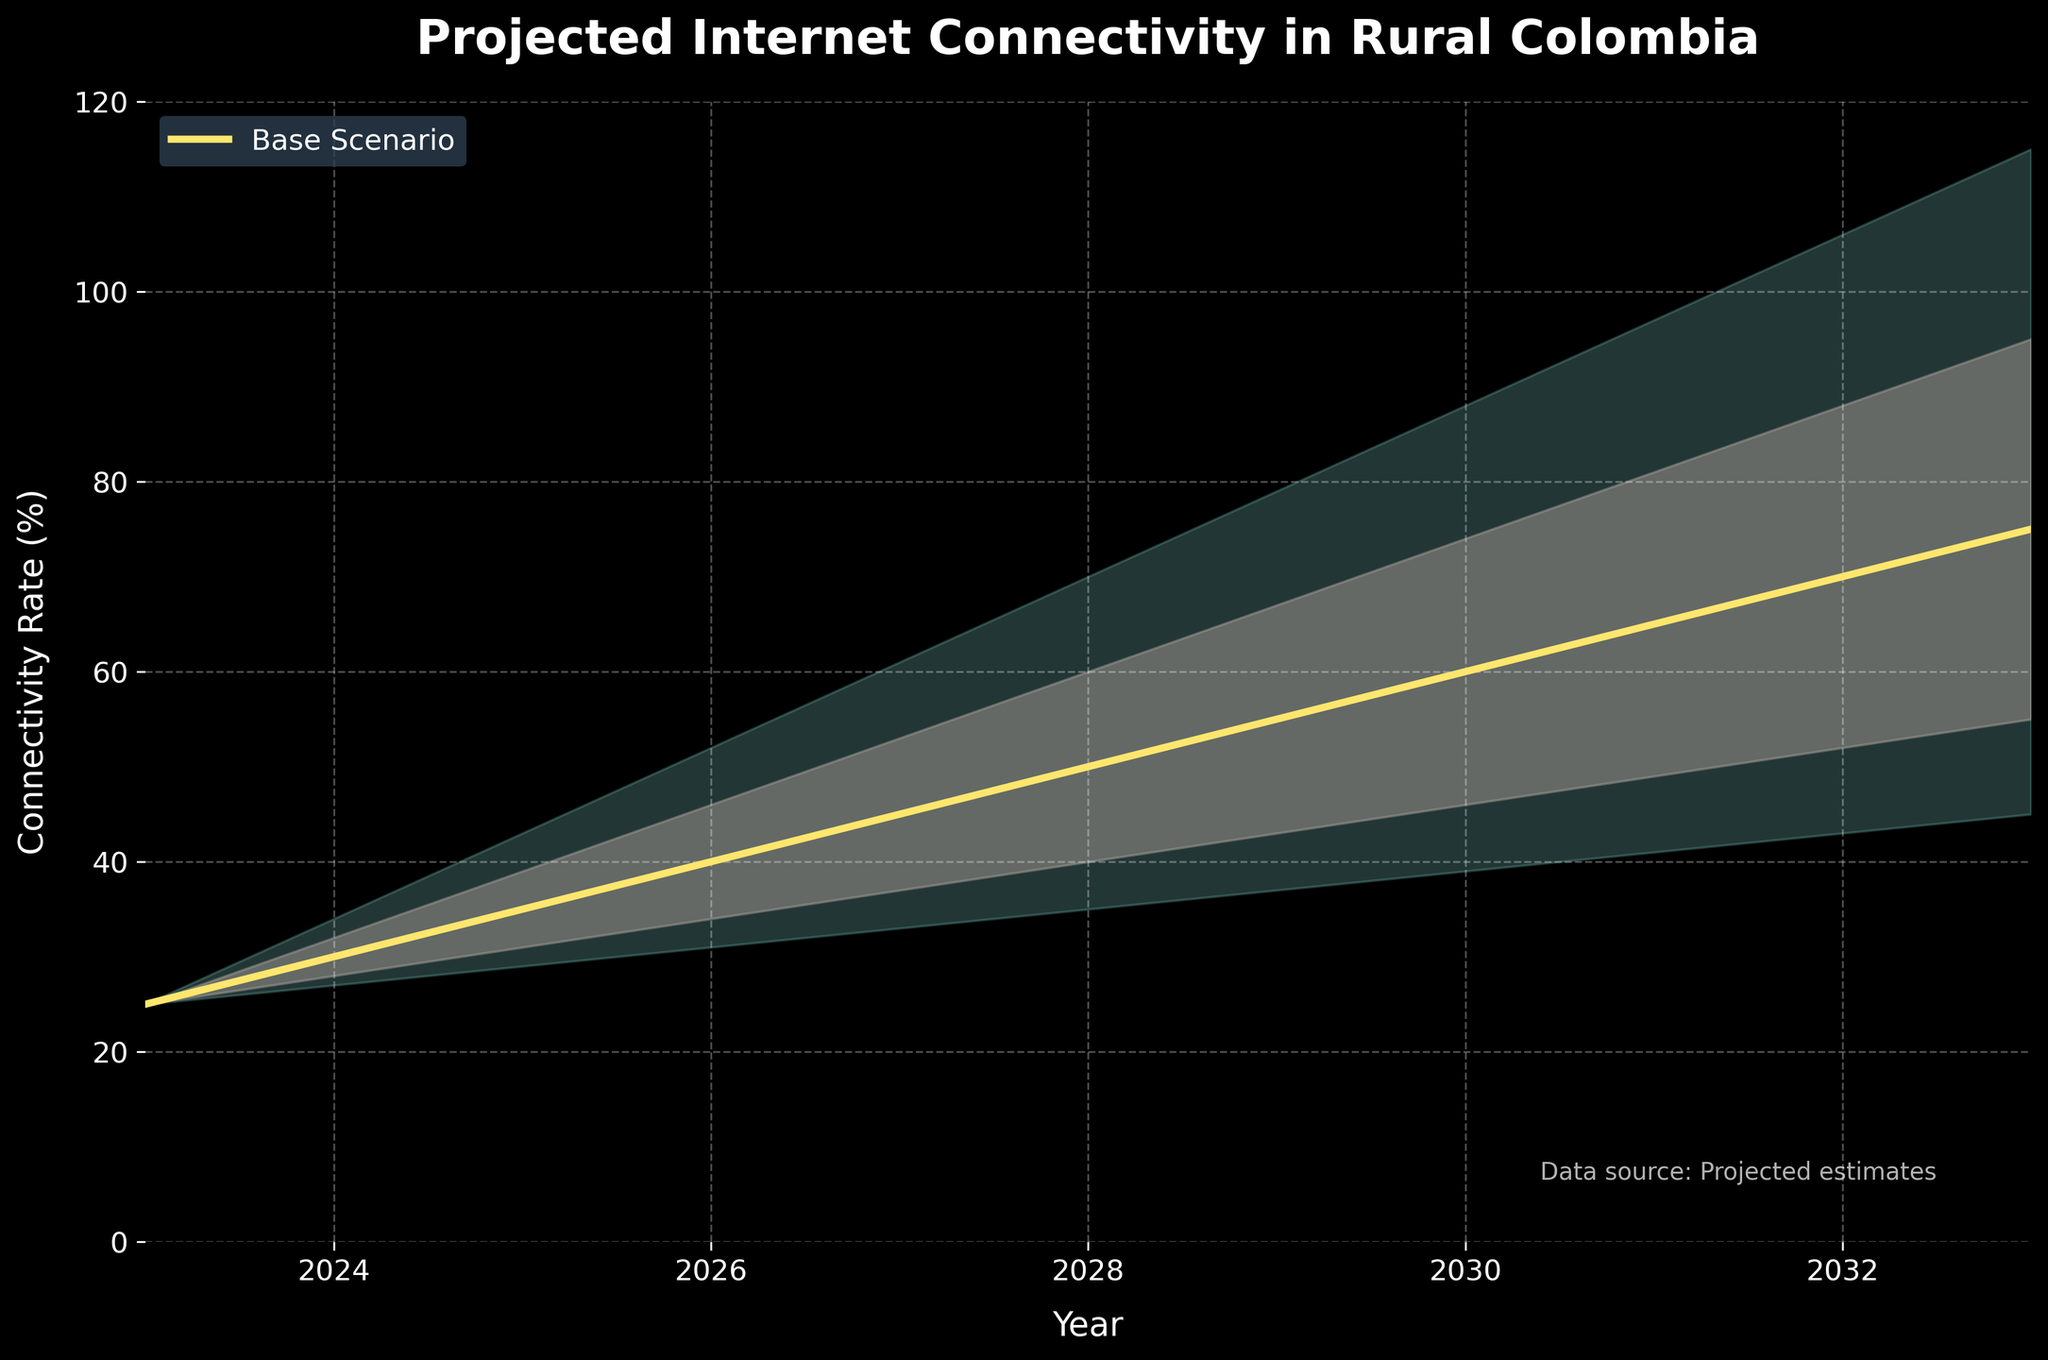What is the title of the chart? The title is written prominently at the top of the chart in large, bold font.
Answer: Projected Internet Connectivity in Rural Colombia What is the predicted connectivity rate in 2025 based on the base scenario? Locate the year 2025 on the x-axis and follow it up to the yellow line (base scenario). Read the corresponding y-value.
Answer: 35% What are the colors used in the chart to represent different scenarios? Analyzing the chart, the base scenario is represented by a yellow color, the optimistic and pessimistic ranges are represented by a gradient of colors from light to dark.
Answer: Yellow for base, gradient shades for others How does the connectivity rate in 2026 for the base scenario compare to the optimistic scenario? Find the year 2026 on the x-axis, then compare the y-values for the base scenario (yellow line) and the optimistic scenario (upper boundary of the shaded area).
Answer: Base: 40%, Optimistic: 52% What is the range between the pessimistic and optimistic scenarios in 2029? For the year 2029, determine the y-values for both the pessimistic and optimistic scenarios and calculate the difference.
Answer: 37 (79% - 42%) How many years are projected in the chart? Count the number of years along the x-axis from 2023 to 2033.
Answer: 11 years By how much does the base scenario connectivity rate increase between 2024 and 2028? Find the base scenario rates for the years 2024 and 2028 and subtract the earlier from the later.
Answer: 20% (50% - 30%) What is the predicted connectivity range in 2033 according to the chart? Locate 2033 on the x-axis and check the y-values for the pessimistic and optimistic scenarios.
Answer: 45% to 115% Is the rate of increase in connectivity faster in the early years (2023-2025) or later years (2030-2033) according to the base scenario? Compare the differences in the y-values of the base scenario between 2023-2025 and 2030-2033.
Answer: Faster in the later years (35% vs. 25%) In which year does the base scenario first predict a connectivity rate of at least 60%? Follow the yellow line of the base scenario upwards from suitable years to determine the first year it crosses 60%.
Answer: 2030 